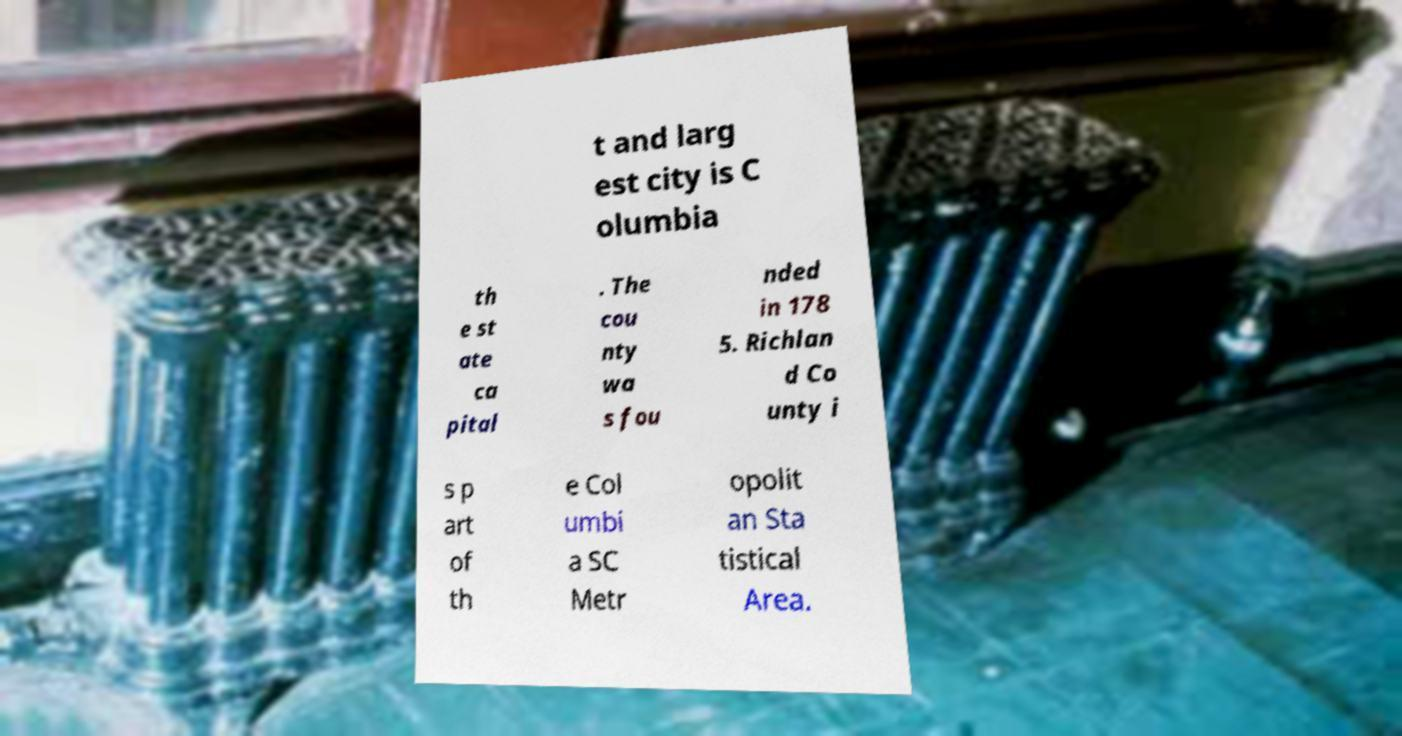Could you assist in decoding the text presented in this image and type it out clearly? t and larg est city is C olumbia th e st ate ca pital . The cou nty wa s fou nded in 178 5. Richlan d Co unty i s p art of th e Col umbi a SC Metr opolit an Sta tistical Area. 